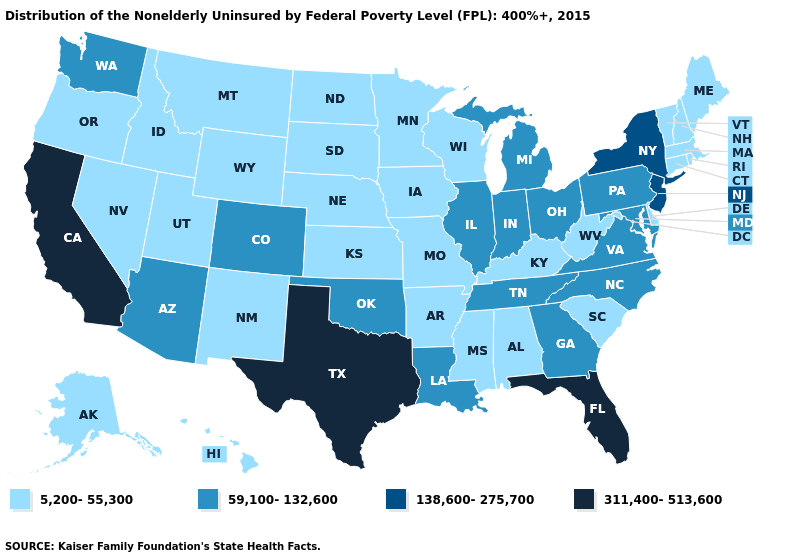What is the value of Montana?
Be succinct. 5,200-55,300. Which states have the highest value in the USA?
Keep it brief. California, Florida, Texas. Does California have the highest value in the West?
Short answer required. Yes. Name the states that have a value in the range 311,400-513,600?
Concise answer only. California, Florida, Texas. Which states have the lowest value in the South?
Give a very brief answer. Alabama, Arkansas, Delaware, Kentucky, Mississippi, South Carolina, West Virginia. Does North Dakota have the highest value in the USA?
Quick response, please. No. Name the states that have a value in the range 138,600-275,700?
Answer briefly. New Jersey, New York. Does Florida have the highest value in the USA?
Concise answer only. Yes. Does Utah have the lowest value in the USA?
Short answer required. Yes. What is the value of Washington?
Short answer required. 59,100-132,600. Name the states that have a value in the range 311,400-513,600?
Short answer required. California, Florida, Texas. Name the states that have a value in the range 311,400-513,600?
Be succinct. California, Florida, Texas. What is the value of Iowa?
Answer briefly. 5,200-55,300. 